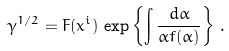Convert formula to latex. <formula><loc_0><loc_0><loc_500><loc_500>\gamma ^ { 1 / 2 } = F ( x ^ { i } ) \, \exp \left \{ \int { \frac { d \alpha } { \alpha f ( \alpha ) } } \right \} \, .</formula> 